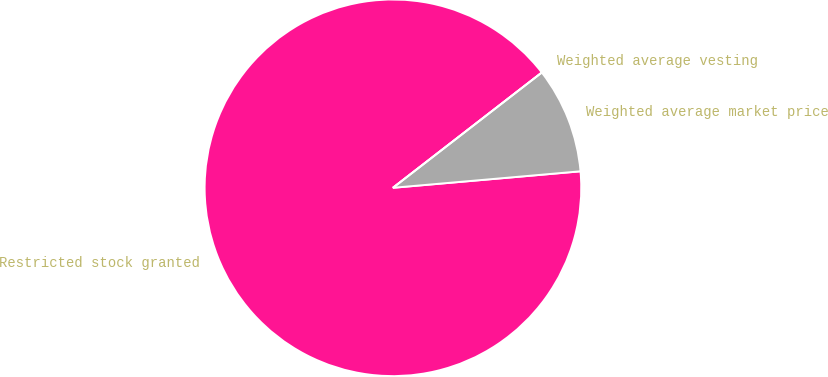Convert chart. <chart><loc_0><loc_0><loc_500><loc_500><pie_chart><fcel>Restricted stock granted<fcel>Weighted average market price<fcel>Weighted average vesting<nl><fcel>90.91%<fcel>9.09%<fcel>0.0%<nl></chart> 